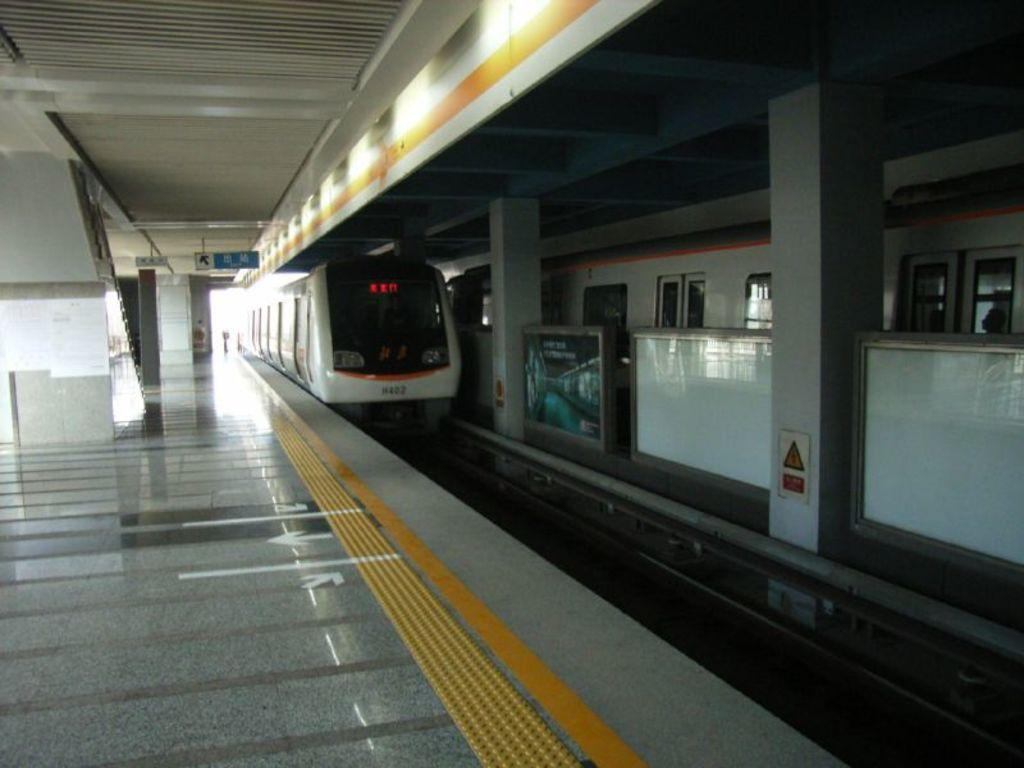What is the main subject of the image? The main subject of the image is a train on the track. What other structures or objects can be seen in the image? There are pillars, a board, and a platform visible in the image. Where might the image have been taken from? The image is likely taken from a platform, as there is a platform present in the image. What type of limit can be seen on the behavior of the train in the image? There is no limit or behavior related to the train mentioned in the image; it is a static image of a train on the track. 